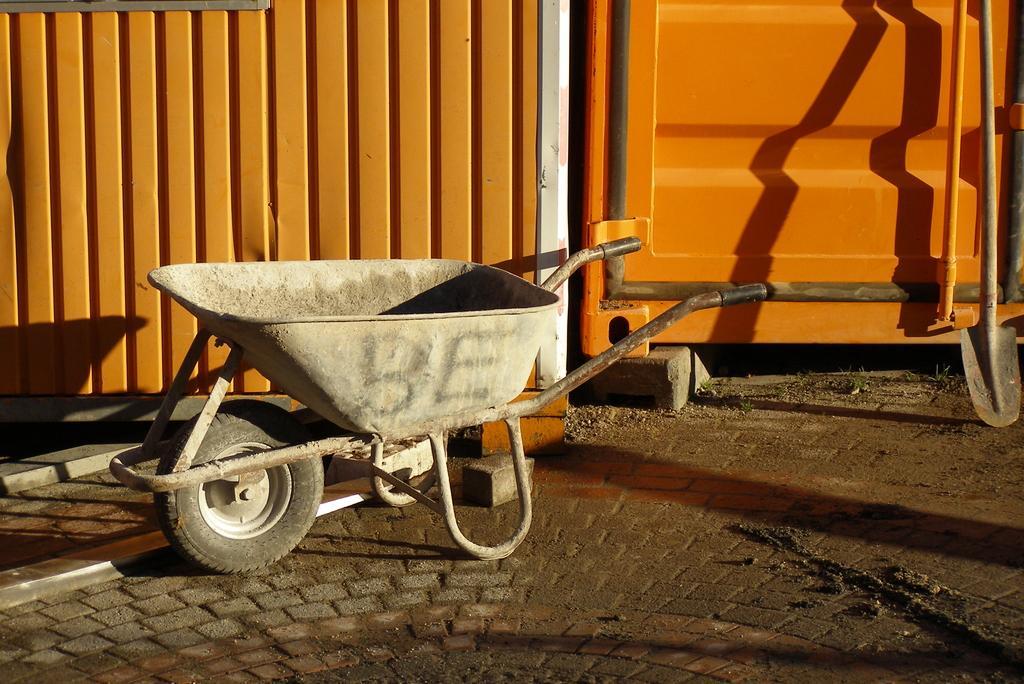Describe this image in one or two sentences. In this image there is one trolley in middle of this image and there is a iron gate in the background which is in re color and there is a digger at right side of this image. 